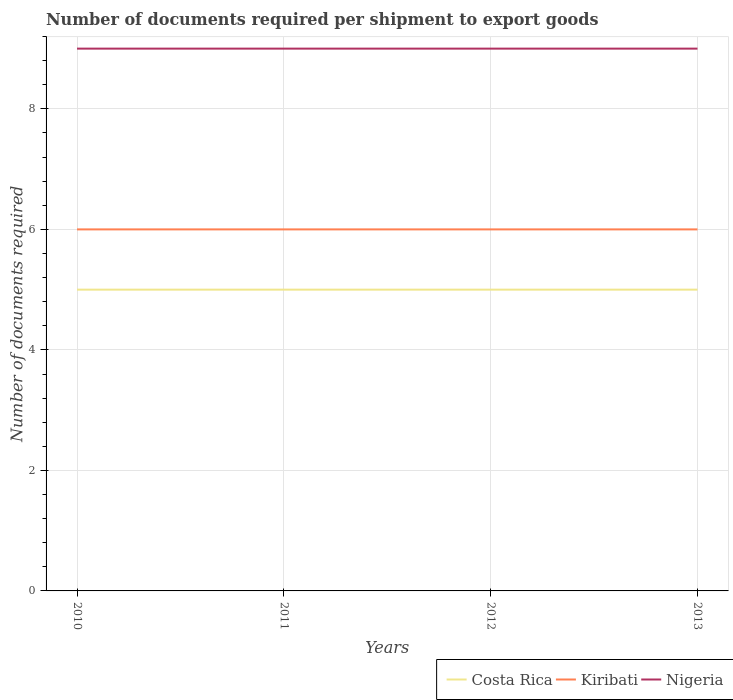How many different coloured lines are there?
Provide a short and direct response. 3. Does the line corresponding to Costa Rica intersect with the line corresponding to Nigeria?
Keep it short and to the point. No. Is the number of lines equal to the number of legend labels?
Make the answer very short. Yes. Across all years, what is the maximum number of documents required per shipment to export goods in Kiribati?
Ensure brevity in your answer.  6. In which year was the number of documents required per shipment to export goods in Nigeria maximum?
Give a very brief answer. 2010. What is the difference between the highest and the lowest number of documents required per shipment to export goods in Nigeria?
Give a very brief answer. 0. What is the difference between two consecutive major ticks on the Y-axis?
Provide a short and direct response. 2. Does the graph contain any zero values?
Make the answer very short. No. What is the title of the graph?
Ensure brevity in your answer.  Number of documents required per shipment to export goods. Does "Euro area" appear as one of the legend labels in the graph?
Your answer should be very brief. No. What is the label or title of the X-axis?
Your answer should be compact. Years. What is the label or title of the Y-axis?
Offer a very short reply. Number of documents required. What is the Number of documents required of Costa Rica in 2010?
Offer a very short reply. 5. What is the Number of documents required of Costa Rica in 2011?
Your answer should be compact. 5. What is the Number of documents required of Kiribati in 2011?
Keep it short and to the point. 6. What is the Number of documents required of Nigeria in 2011?
Your answer should be compact. 9. What is the Number of documents required in Kiribati in 2012?
Make the answer very short. 6. What is the Number of documents required in Nigeria in 2012?
Offer a terse response. 9. Across all years, what is the maximum Number of documents required of Kiribati?
Provide a succinct answer. 6. Across all years, what is the maximum Number of documents required of Nigeria?
Provide a succinct answer. 9. Across all years, what is the minimum Number of documents required in Kiribati?
Your answer should be compact. 6. Across all years, what is the minimum Number of documents required in Nigeria?
Offer a terse response. 9. What is the total Number of documents required of Costa Rica in the graph?
Your answer should be compact. 20. What is the total Number of documents required in Kiribati in the graph?
Offer a terse response. 24. What is the difference between the Number of documents required in Costa Rica in 2010 and that in 2011?
Your answer should be compact. 0. What is the difference between the Number of documents required of Kiribati in 2010 and that in 2011?
Offer a very short reply. 0. What is the difference between the Number of documents required of Nigeria in 2010 and that in 2011?
Offer a terse response. 0. What is the difference between the Number of documents required in Costa Rica in 2010 and that in 2012?
Offer a terse response. 0. What is the difference between the Number of documents required in Costa Rica in 2010 and that in 2013?
Provide a succinct answer. 0. What is the difference between the Number of documents required in Kiribati in 2010 and that in 2013?
Provide a short and direct response. 0. What is the difference between the Number of documents required in Nigeria in 2010 and that in 2013?
Make the answer very short. 0. What is the difference between the Number of documents required in Costa Rica in 2011 and that in 2012?
Give a very brief answer. 0. What is the difference between the Number of documents required of Kiribati in 2011 and that in 2012?
Give a very brief answer. 0. What is the difference between the Number of documents required in Costa Rica in 2011 and that in 2013?
Offer a terse response. 0. What is the difference between the Number of documents required of Nigeria in 2011 and that in 2013?
Make the answer very short. 0. What is the difference between the Number of documents required in Costa Rica in 2012 and that in 2013?
Offer a terse response. 0. What is the difference between the Number of documents required of Nigeria in 2012 and that in 2013?
Give a very brief answer. 0. What is the difference between the Number of documents required of Costa Rica in 2010 and the Number of documents required of Nigeria in 2012?
Make the answer very short. -4. What is the difference between the Number of documents required of Kiribati in 2010 and the Number of documents required of Nigeria in 2012?
Offer a terse response. -3. What is the difference between the Number of documents required of Costa Rica in 2010 and the Number of documents required of Kiribati in 2013?
Your answer should be compact. -1. What is the difference between the Number of documents required in Costa Rica in 2011 and the Number of documents required in Kiribati in 2012?
Your answer should be compact. -1. What is the difference between the Number of documents required of Costa Rica in 2011 and the Number of documents required of Nigeria in 2012?
Provide a short and direct response. -4. What is the difference between the Number of documents required in Kiribati in 2011 and the Number of documents required in Nigeria in 2012?
Provide a succinct answer. -3. What is the difference between the Number of documents required of Kiribati in 2011 and the Number of documents required of Nigeria in 2013?
Offer a very short reply. -3. What is the difference between the Number of documents required in Costa Rica in 2012 and the Number of documents required in Nigeria in 2013?
Offer a terse response. -4. What is the difference between the Number of documents required of Kiribati in 2012 and the Number of documents required of Nigeria in 2013?
Provide a succinct answer. -3. What is the average Number of documents required of Kiribati per year?
Provide a succinct answer. 6. What is the average Number of documents required of Nigeria per year?
Give a very brief answer. 9. In the year 2010, what is the difference between the Number of documents required of Costa Rica and Number of documents required of Kiribati?
Your answer should be compact. -1. In the year 2010, what is the difference between the Number of documents required in Costa Rica and Number of documents required in Nigeria?
Your response must be concise. -4. In the year 2010, what is the difference between the Number of documents required of Kiribati and Number of documents required of Nigeria?
Offer a very short reply. -3. In the year 2011, what is the difference between the Number of documents required of Costa Rica and Number of documents required of Nigeria?
Make the answer very short. -4. In the year 2012, what is the difference between the Number of documents required in Costa Rica and Number of documents required in Kiribati?
Your response must be concise. -1. In the year 2012, what is the difference between the Number of documents required of Costa Rica and Number of documents required of Nigeria?
Keep it short and to the point. -4. What is the ratio of the Number of documents required in Costa Rica in 2010 to that in 2011?
Provide a succinct answer. 1. What is the ratio of the Number of documents required in Kiribati in 2010 to that in 2011?
Keep it short and to the point. 1. What is the ratio of the Number of documents required of Kiribati in 2010 to that in 2013?
Your answer should be very brief. 1. What is the ratio of the Number of documents required of Nigeria in 2010 to that in 2013?
Ensure brevity in your answer.  1. What is the ratio of the Number of documents required in Kiribati in 2011 to that in 2012?
Your answer should be very brief. 1. What is the ratio of the Number of documents required of Nigeria in 2011 to that in 2012?
Your answer should be compact. 1. What is the ratio of the Number of documents required in Kiribati in 2011 to that in 2013?
Ensure brevity in your answer.  1. What is the ratio of the Number of documents required in Nigeria in 2011 to that in 2013?
Make the answer very short. 1. What is the difference between the highest and the second highest Number of documents required in Costa Rica?
Ensure brevity in your answer.  0. What is the difference between the highest and the second highest Number of documents required of Nigeria?
Your answer should be very brief. 0. What is the difference between the highest and the lowest Number of documents required of Nigeria?
Ensure brevity in your answer.  0. 